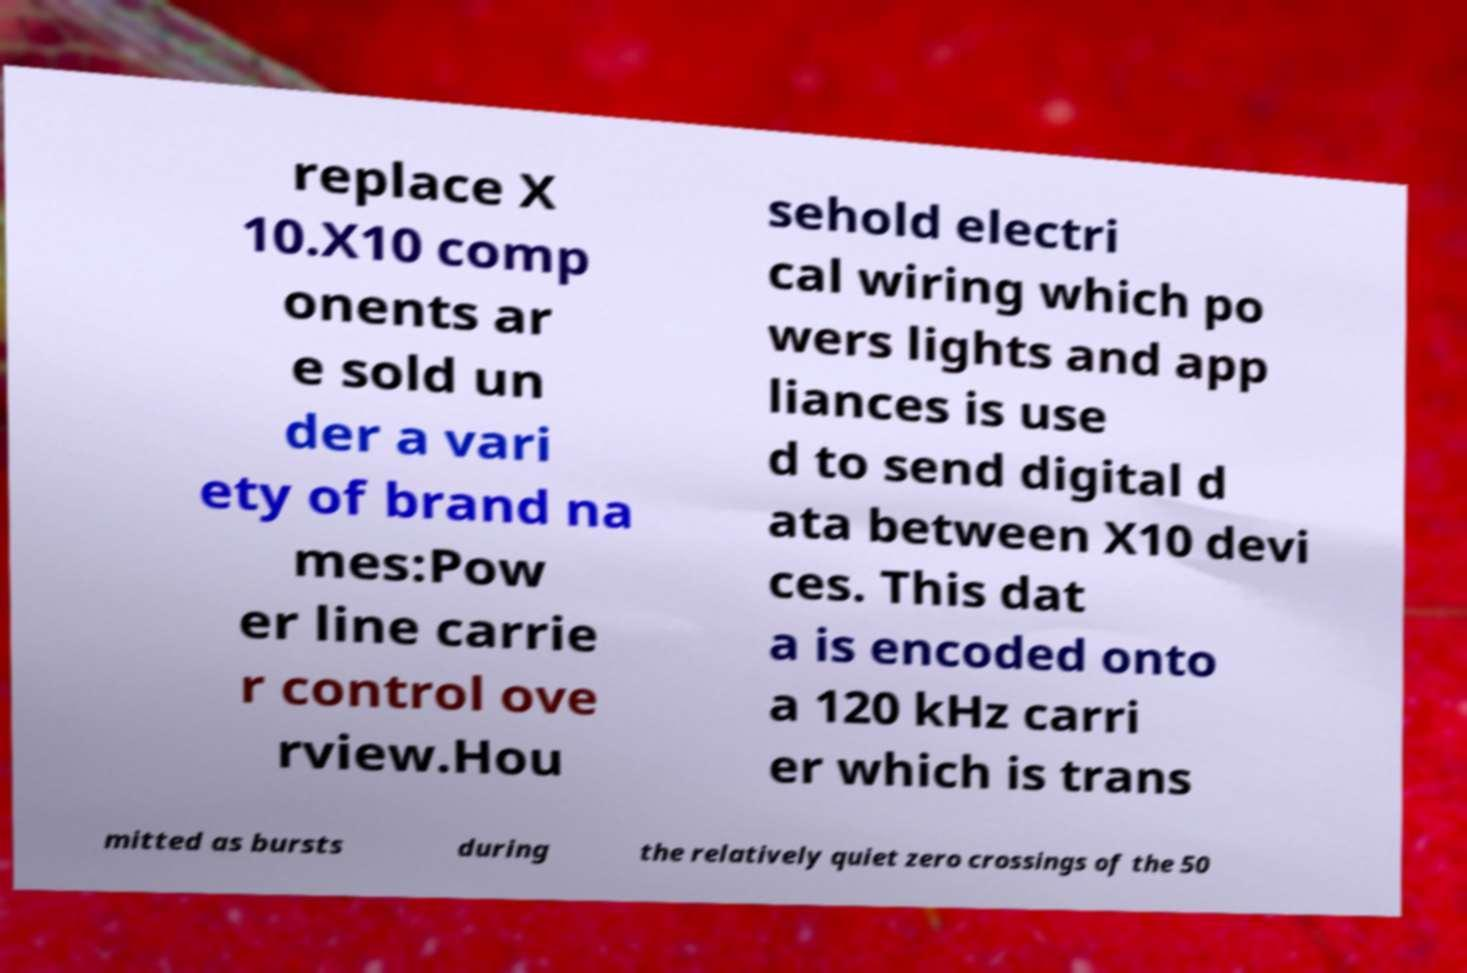Please identify and transcribe the text found in this image. replace X 10.X10 comp onents ar e sold un der a vari ety of brand na mes:Pow er line carrie r control ove rview.Hou sehold electri cal wiring which po wers lights and app liances is use d to send digital d ata between X10 devi ces. This dat a is encoded onto a 120 kHz carri er which is trans mitted as bursts during the relatively quiet zero crossings of the 50 